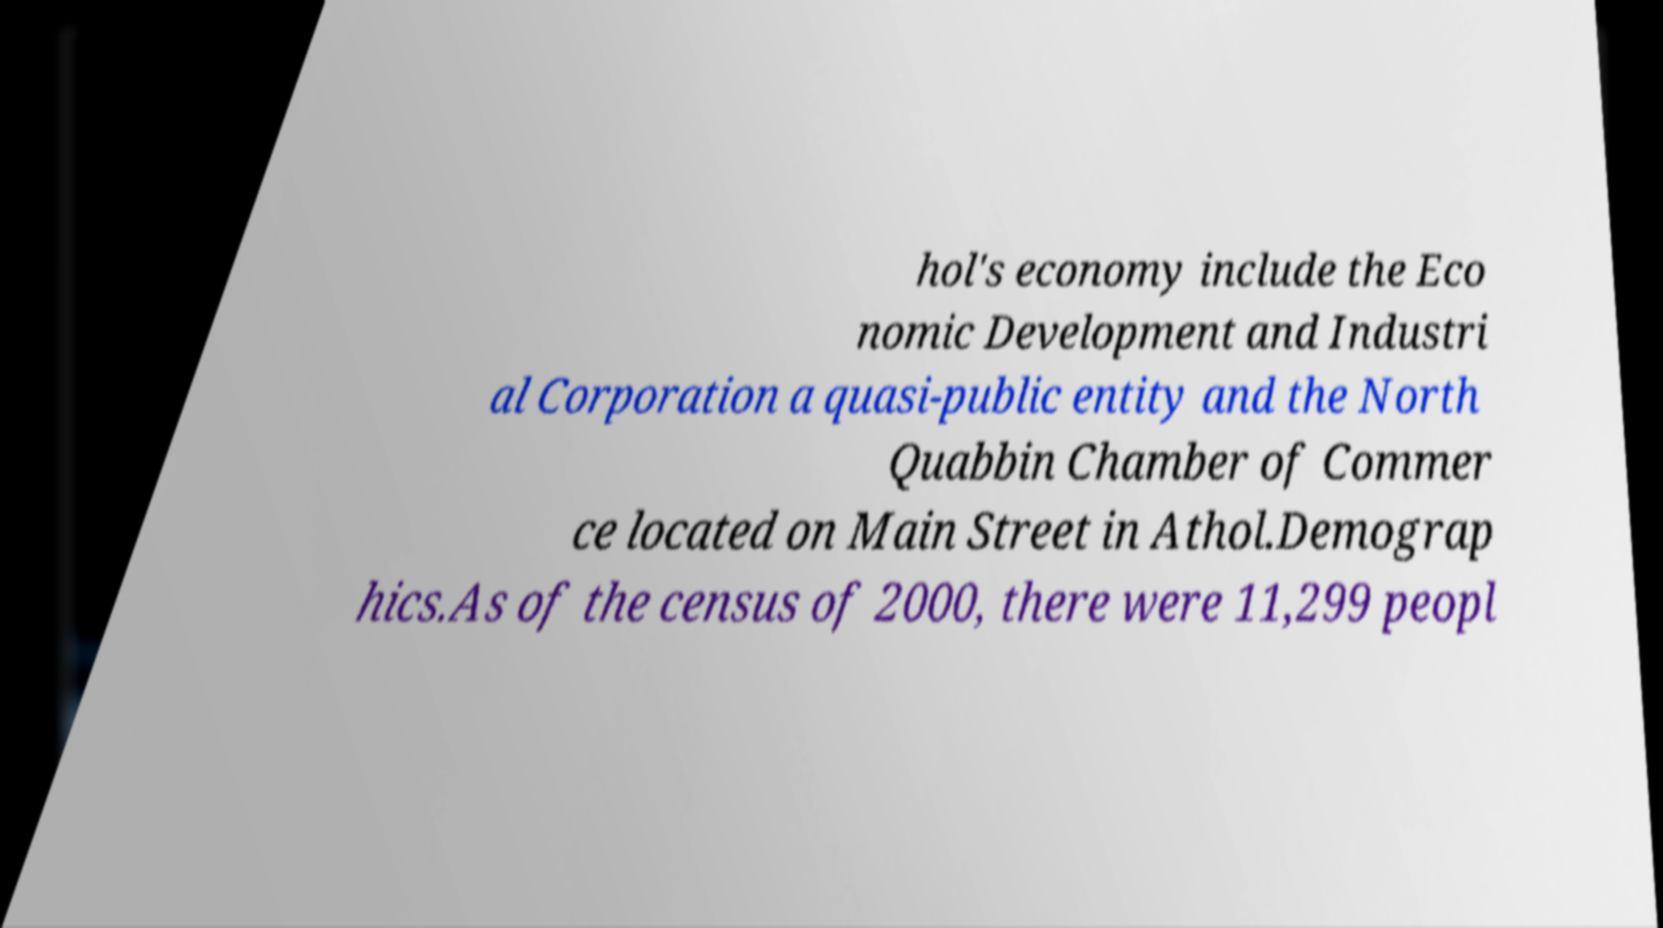Can you read and provide the text displayed in the image?This photo seems to have some interesting text. Can you extract and type it out for me? hol's economy include the Eco nomic Development and Industri al Corporation a quasi-public entity and the North Quabbin Chamber of Commer ce located on Main Street in Athol.Demograp hics.As of the census of 2000, there were 11,299 peopl 